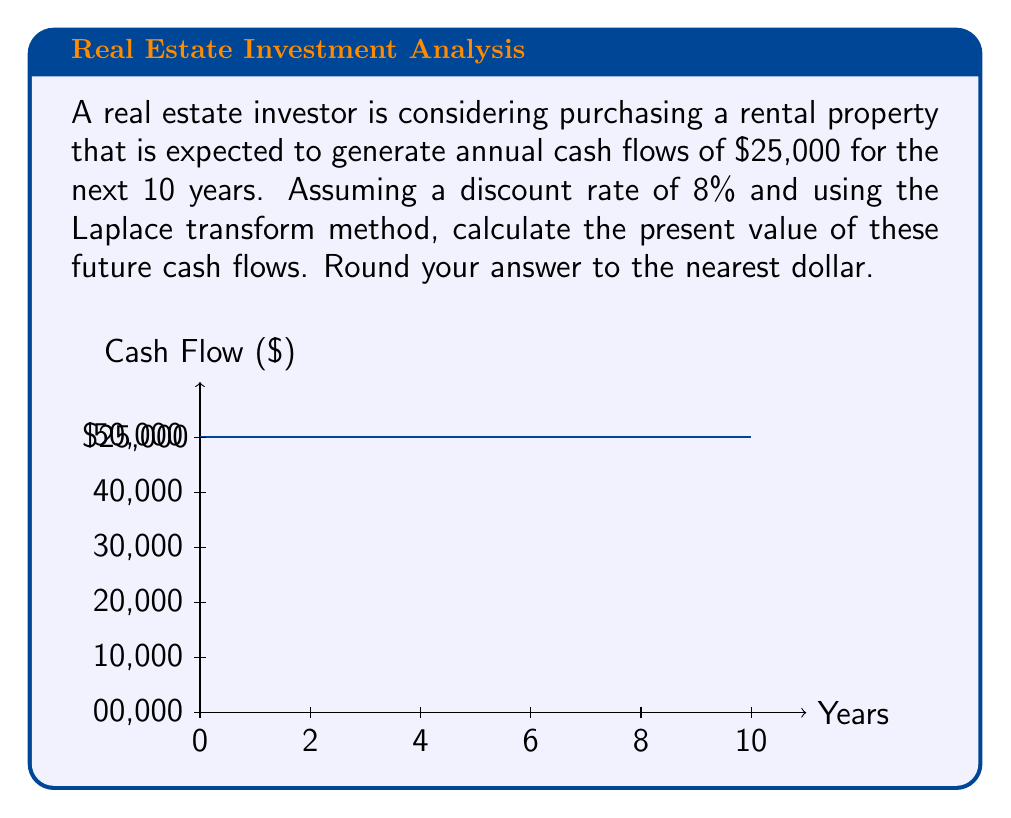Solve this math problem. Let's approach this step-by-step using the Laplace transform method:

1) First, we define our cash flow function in the time domain:
   $$f(t) = 25000 \cdot u(t) - 25000 \cdot u(t-10)$$
   where $u(t)$ is the unit step function.

2) The Laplace transform of this function is:
   $$F(s) = \mathcal{L}\{f(t)\} = \frac{25000}{s} - \frac{25000e^{-10s}}{s}$$

3) To account for the discount rate, we replace $s$ with $(s+0.08)$:
   $$F(s+0.08) = \frac{25000}{s+0.08} - \frac{25000e^{-10(s+0.08)}}{s+0.08}$$

4) The present value is given by $F(0.08)$:
   $$PV = F(0.08) = \frac{25000}{0.08} - \frac{25000e^{-10(0.08)}}{0.08}$$

5) Simplifying:
   $$PV = 312500 - 312500e^{-0.8}$$

6) Calculate $e^{-0.8} \approx 0.4493$:
   $$PV = 312500 - 312500(0.4493) = 312500 - 140406.25$$

7) Final calculation:
   $$PV = 172093.75$$

8) Rounding to the nearest dollar:
   $$PV \approx 172094$$
Answer: $172,094 